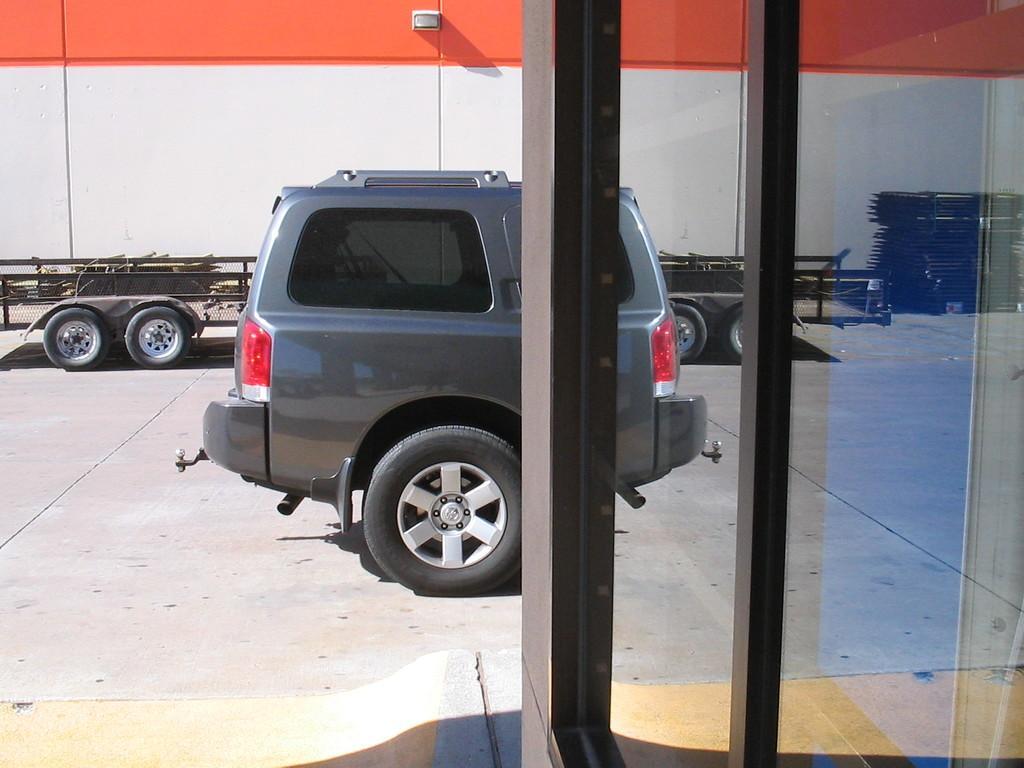Please provide a concise description of this image. In this image I can see the vehicles on the road. I can see the white and an orange color background. To the right I can see the glass. In the glass I can see the reflection of vehicles and few objects. 